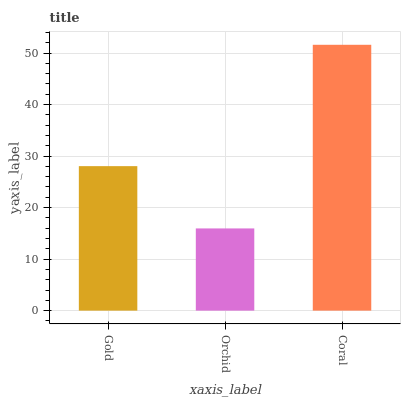Is Orchid the minimum?
Answer yes or no. Yes. Is Coral the maximum?
Answer yes or no. Yes. Is Coral the minimum?
Answer yes or no. No. Is Orchid the maximum?
Answer yes or no. No. Is Coral greater than Orchid?
Answer yes or no. Yes. Is Orchid less than Coral?
Answer yes or no. Yes. Is Orchid greater than Coral?
Answer yes or no. No. Is Coral less than Orchid?
Answer yes or no. No. Is Gold the high median?
Answer yes or no. Yes. Is Gold the low median?
Answer yes or no. Yes. Is Coral the high median?
Answer yes or no. No. Is Coral the low median?
Answer yes or no. No. 